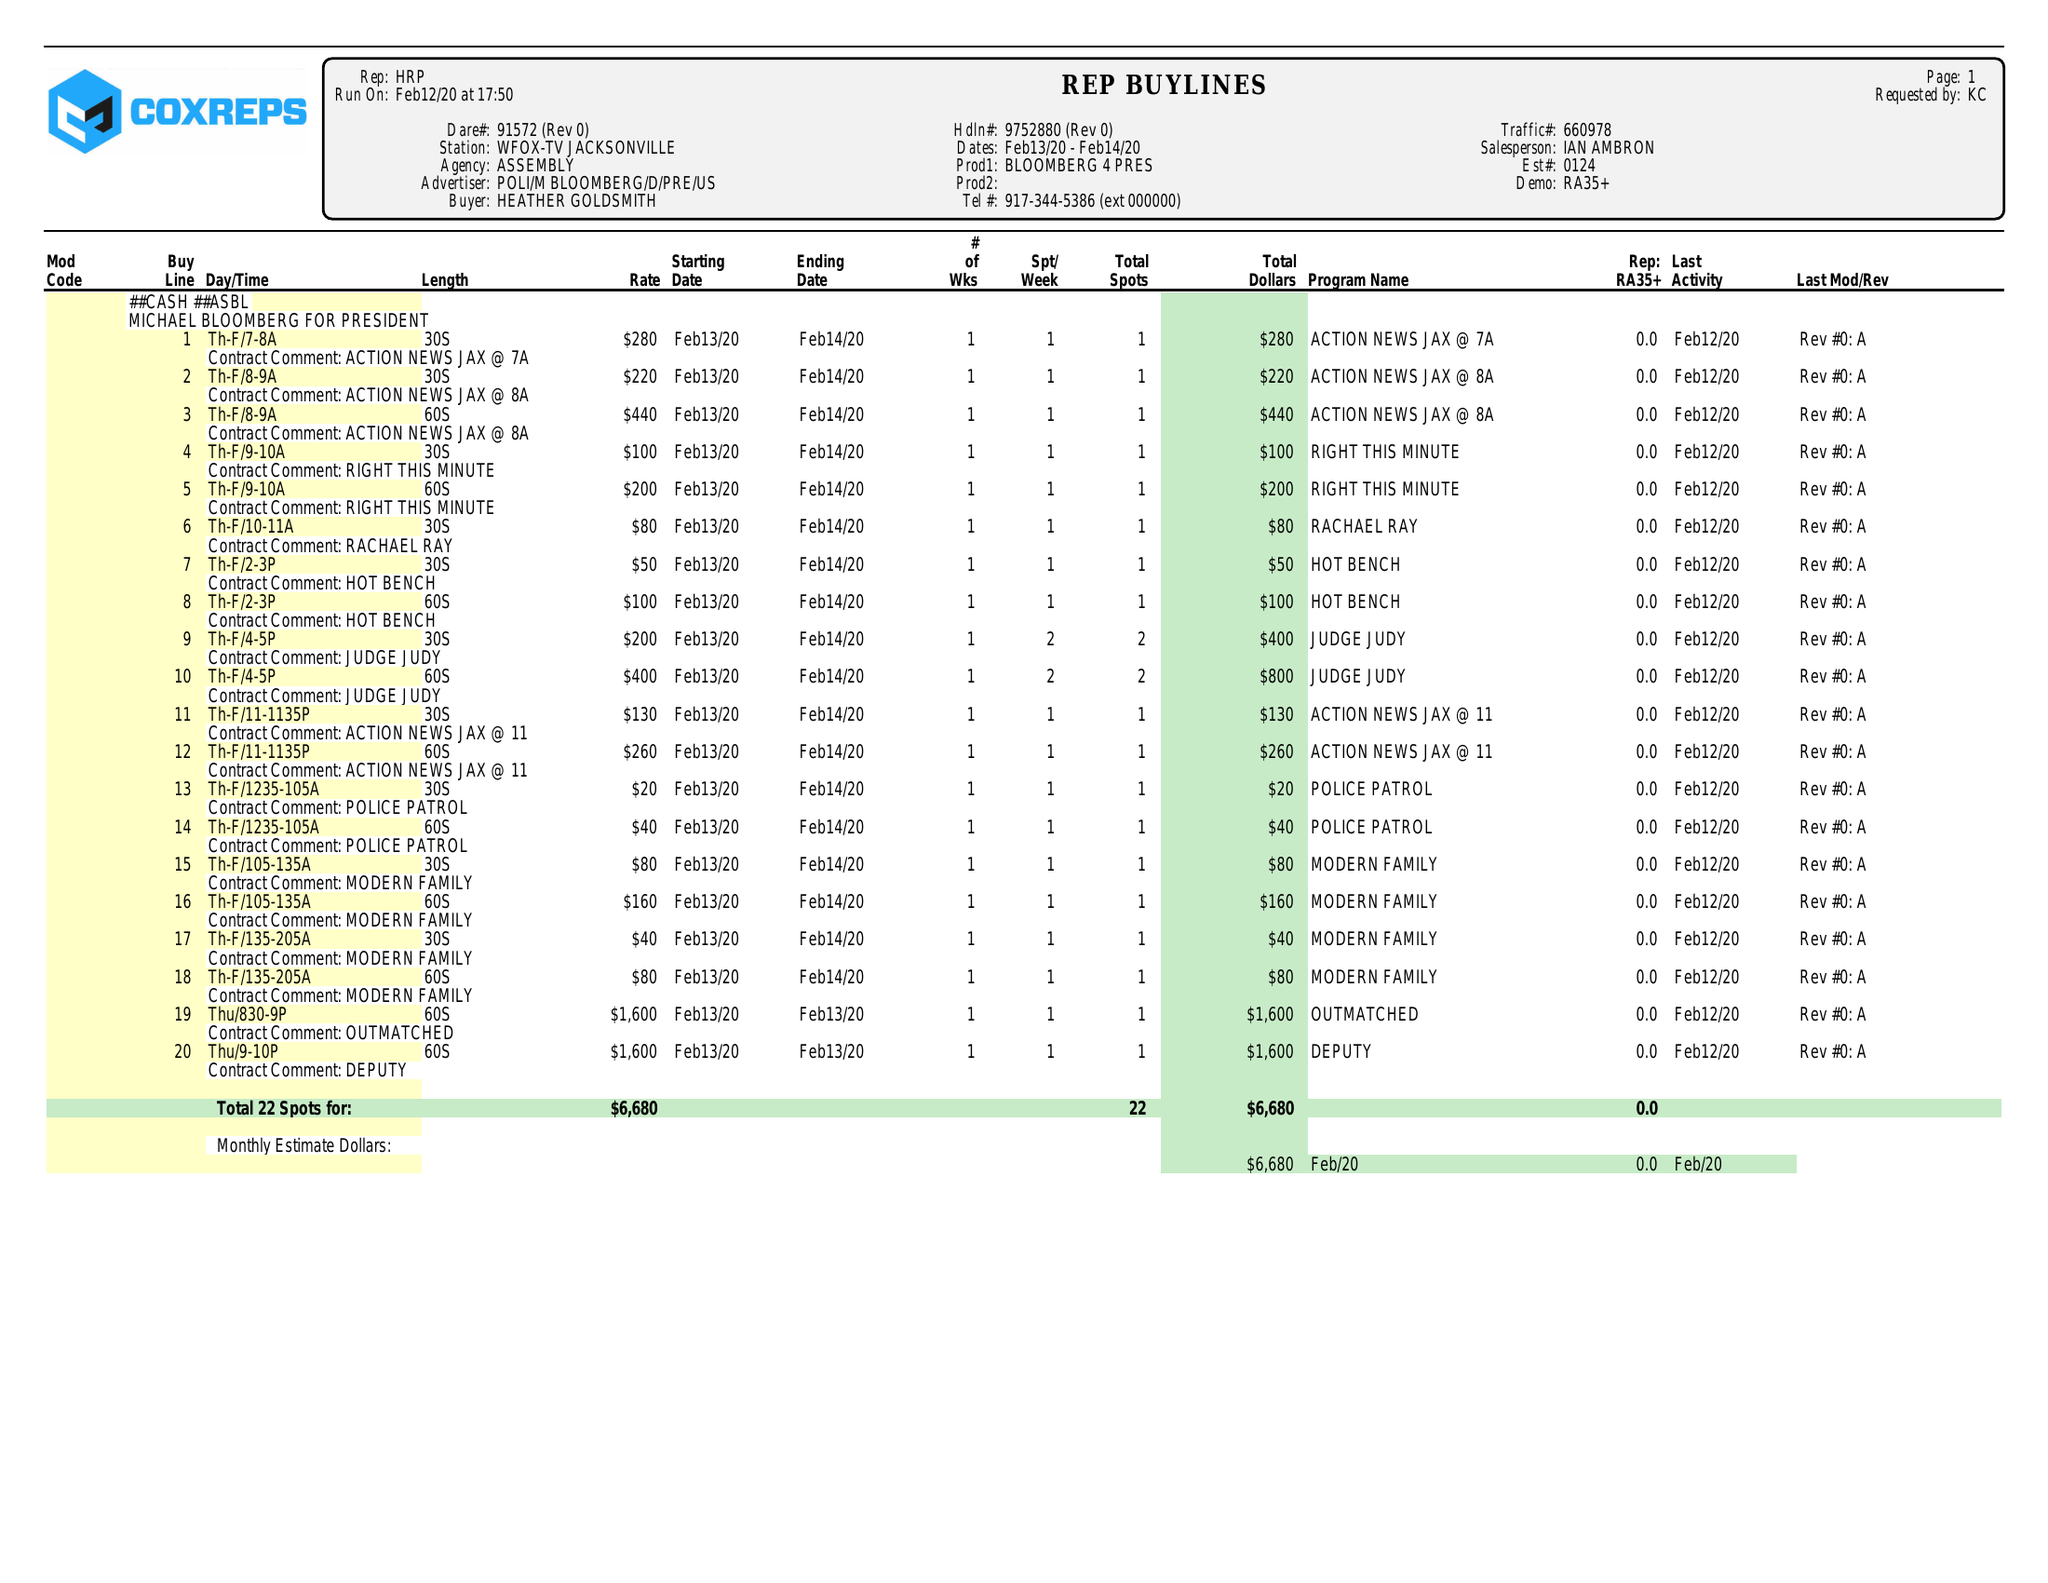What is the value for the contract_num?
Answer the question using a single word or phrase. 9752880 